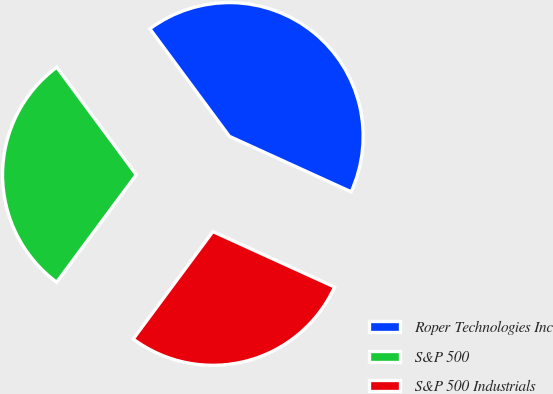Convert chart to OTSL. <chart><loc_0><loc_0><loc_500><loc_500><pie_chart><fcel>Roper Technologies Inc<fcel>S&P 500<fcel>S&P 500 Industrials<nl><fcel>41.94%<fcel>29.71%<fcel>28.35%<nl></chart> 